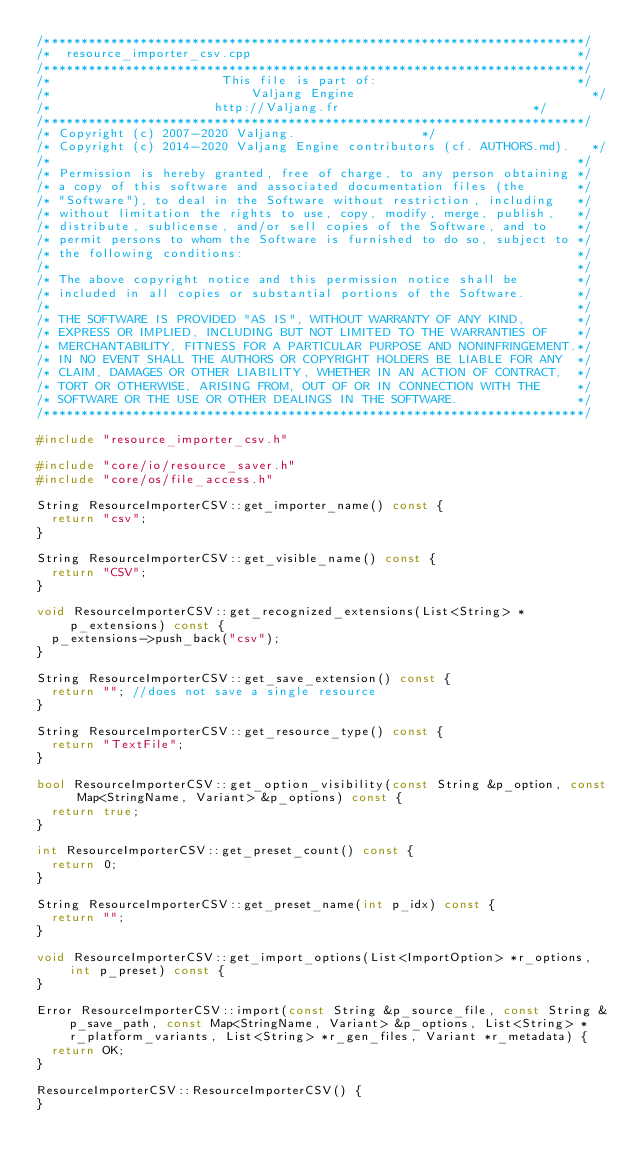<code> <loc_0><loc_0><loc_500><loc_500><_C++_>/*************************************************************************/
/*  resource_importer_csv.cpp                                            */
/*************************************************************************/
/*                       This file is part of:                           */
/*                           Valjang Engine                                */
/*                      http://Valjang.fr                          */
/*************************************************************************/
/* Copyright (c) 2007-2020 Valjang.                 */
/* Copyright (c) 2014-2020 Valjang Engine contributors (cf. AUTHORS.md).   */
/*                                                                       */
/* Permission is hereby granted, free of charge, to any person obtaining */
/* a copy of this software and associated documentation files (the       */
/* "Software"), to deal in the Software without restriction, including   */
/* without limitation the rights to use, copy, modify, merge, publish,   */
/* distribute, sublicense, and/or sell copies of the Software, and to    */
/* permit persons to whom the Software is furnished to do so, subject to */
/* the following conditions:                                             */
/*                                                                       */
/* The above copyright notice and this permission notice shall be        */
/* included in all copies or substantial portions of the Software.       */
/*                                                                       */
/* THE SOFTWARE IS PROVIDED "AS IS", WITHOUT WARRANTY OF ANY KIND,       */
/* EXPRESS OR IMPLIED, INCLUDING BUT NOT LIMITED TO THE WARRANTIES OF    */
/* MERCHANTABILITY, FITNESS FOR A PARTICULAR PURPOSE AND NONINFRINGEMENT.*/
/* IN NO EVENT SHALL THE AUTHORS OR COPYRIGHT HOLDERS BE LIABLE FOR ANY  */
/* CLAIM, DAMAGES OR OTHER LIABILITY, WHETHER IN AN ACTION OF CONTRACT,  */
/* TORT OR OTHERWISE, ARISING FROM, OUT OF OR IN CONNECTION WITH THE     */
/* SOFTWARE OR THE USE OR OTHER DEALINGS IN THE SOFTWARE.                */
/*************************************************************************/

#include "resource_importer_csv.h"

#include "core/io/resource_saver.h"
#include "core/os/file_access.h"

String ResourceImporterCSV::get_importer_name() const {
	return "csv";
}

String ResourceImporterCSV::get_visible_name() const {
	return "CSV";
}

void ResourceImporterCSV::get_recognized_extensions(List<String> *p_extensions) const {
	p_extensions->push_back("csv");
}

String ResourceImporterCSV::get_save_extension() const {
	return ""; //does not save a single resource
}

String ResourceImporterCSV::get_resource_type() const {
	return "TextFile";
}

bool ResourceImporterCSV::get_option_visibility(const String &p_option, const Map<StringName, Variant> &p_options) const {
	return true;
}

int ResourceImporterCSV::get_preset_count() const {
	return 0;
}

String ResourceImporterCSV::get_preset_name(int p_idx) const {
	return "";
}

void ResourceImporterCSV::get_import_options(List<ImportOption> *r_options, int p_preset) const {
}

Error ResourceImporterCSV::import(const String &p_source_file, const String &p_save_path, const Map<StringName, Variant> &p_options, List<String> *r_platform_variants, List<String> *r_gen_files, Variant *r_metadata) {
	return OK;
}

ResourceImporterCSV::ResourceImporterCSV() {
}
</code> 